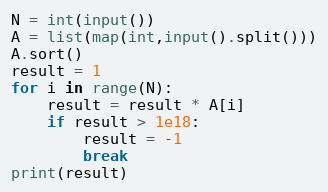Convert code to text. <code><loc_0><loc_0><loc_500><loc_500><_Python_>N = int(input())
A = list(map(int,input().split()))
A.sort()
result = 1
for i in range(N):
    result = result * A[i]
    if result > 1e18:
        result = -1
        break
print(result)</code> 